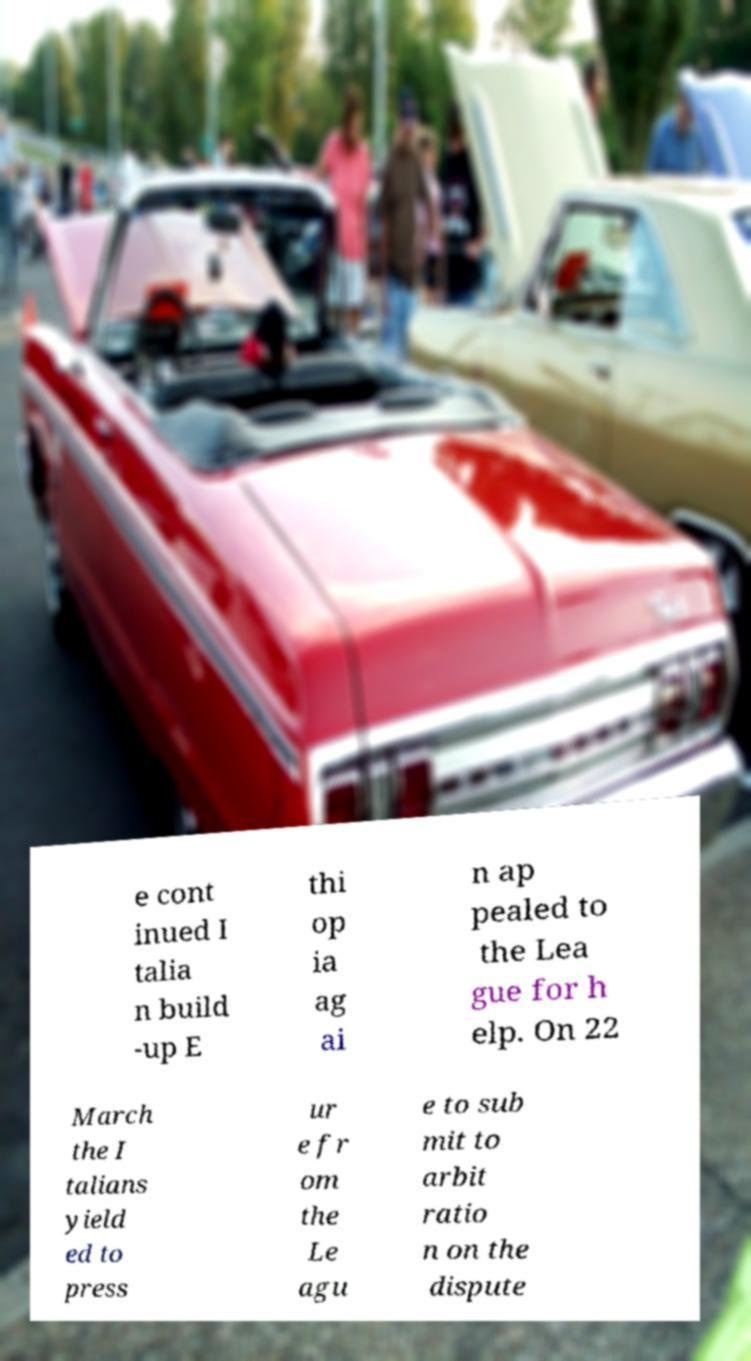Can you read and provide the text displayed in the image?This photo seems to have some interesting text. Can you extract and type it out for me? e cont inued I talia n build -up E thi op ia ag ai n ap pealed to the Lea gue for h elp. On 22 March the I talians yield ed to press ur e fr om the Le agu e to sub mit to arbit ratio n on the dispute 